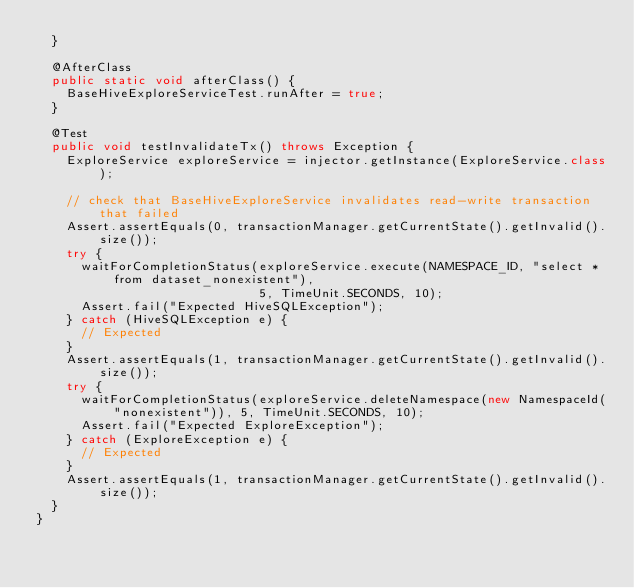<code> <loc_0><loc_0><loc_500><loc_500><_Java_>  }

  @AfterClass
  public static void afterClass() {
    BaseHiveExploreServiceTest.runAfter = true;
  }

  @Test
  public void testInvalidateTx() throws Exception {
    ExploreService exploreService = injector.getInstance(ExploreService.class);

    // check that BaseHiveExploreService invalidates read-write transaction that failed
    Assert.assertEquals(0, transactionManager.getCurrentState().getInvalid().size());
    try {
      waitForCompletionStatus(exploreService.execute(NAMESPACE_ID, "select * from dataset_nonexistent"),
                              5, TimeUnit.SECONDS, 10);
      Assert.fail("Expected HiveSQLException");
    } catch (HiveSQLException e) {
      // Expected
    }
    Assert.assertEquals(1, transactionManager.getCurrentState().getInvalid().size());
    try {
      waitForCompletionStatus(exploreService.deleteNamespace(new NamespaceId("nonexistent")), 5, TimeUnit.SECONDS, 10);
      Assert.fail("Expected ExploreException");
    } catch (ExploreException e) {
      // Expected
    }
    Assert.assertEquals(1, transactionManager.getCurrentState().getInvalid().size());
  }
}
</code> 